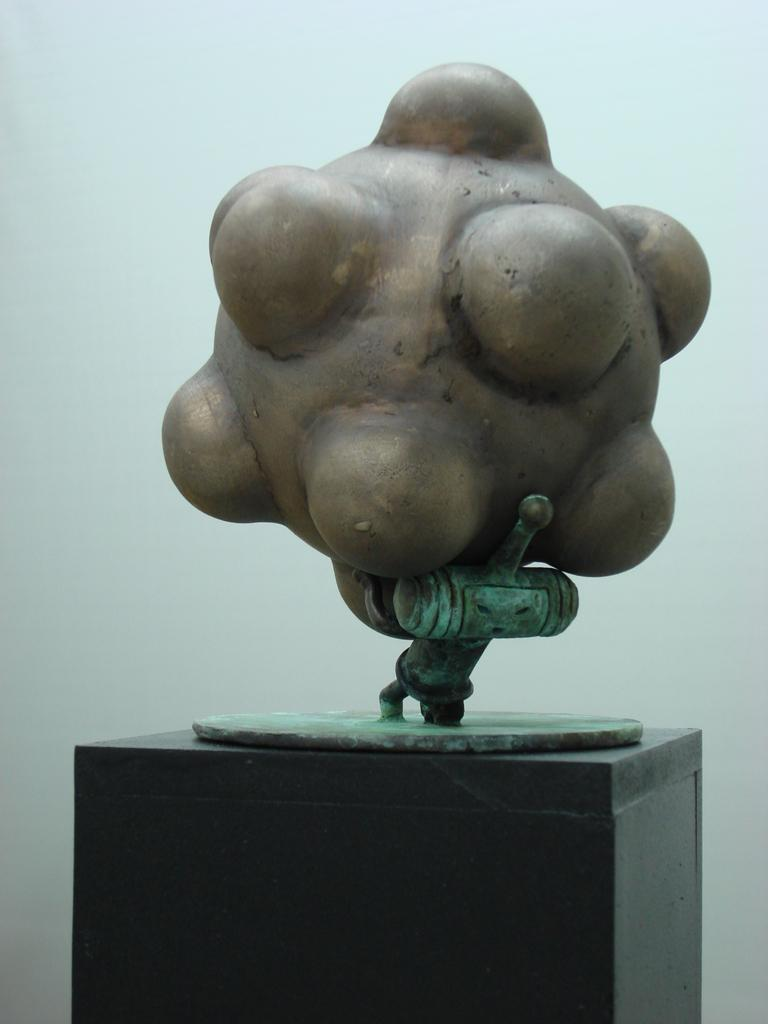What is the main subject in the image? There is a sculpture in the image. What is located at the bottom of the image? There is a table at the bottom of the image. What is situated at the back of the image? There is a wall at the back of the image. What type of shoes can be seen on the sculpture in the image? There are no shoes present on the sculpture in the image. What type of ray is visible in the image? There is no ray present in the image. What type of pollution is depicted in the image? There is no depiction of pollution in the image. 